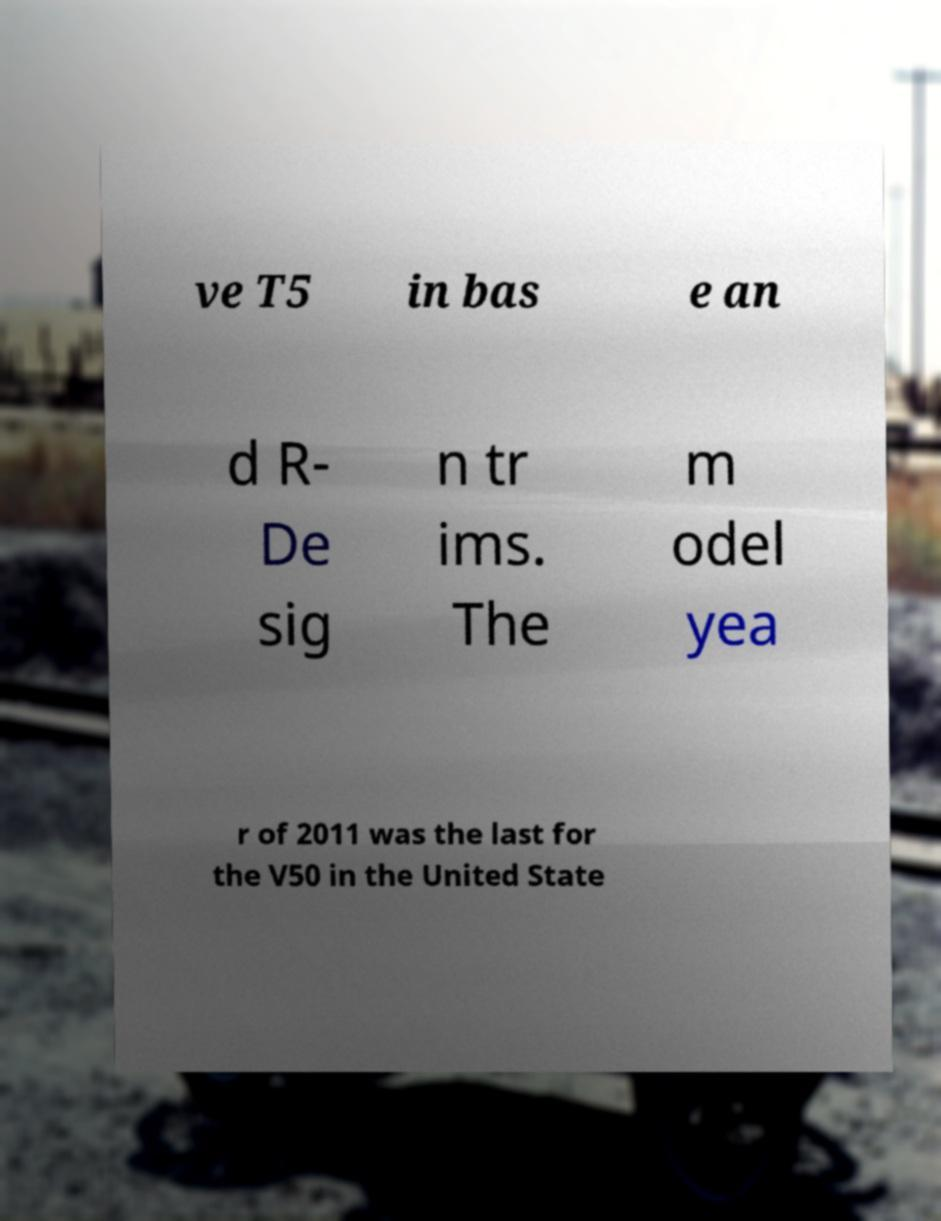Please read and relay the text visible in this image. What does it say? ve T5 in bas e an d R- De sig n tr ims. The m odel yea r of 2011 was the last for the V50 in the United State 